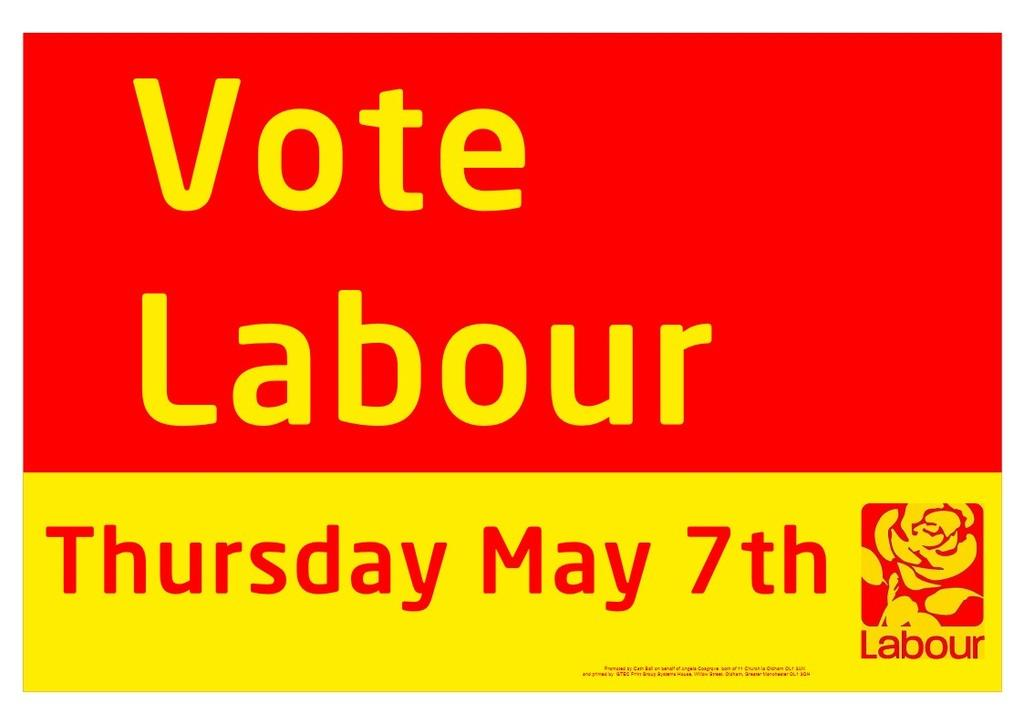<image>
Give a short and clear explanation of the subsequent image. a red and yellow advertisement that reads vote labour with the labour logo on the bottom right. 